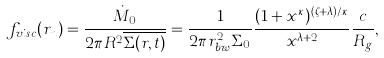Convert formula to latex. <formula><loc_0><loc_0><loc_500><loc_500>f _ { v i s c } ( r _ { n } ) = \frac { \dot { M } _ { 0 } } { 2 \pi R ^ { 2 } \overline { \Sigma ( r , t ) } } = \frac { 1 } { 2 \pi r _ { b w } ^ { 2 } \Sigma _ { 0 } } \frac { ( 1 + x ^ { \kappa } ) ^ { ( \zeta + \lambda ) / \kappa } } { x ^ { \lambda + 2 } } \frac { c } { R _ { g } } ,</formula> 